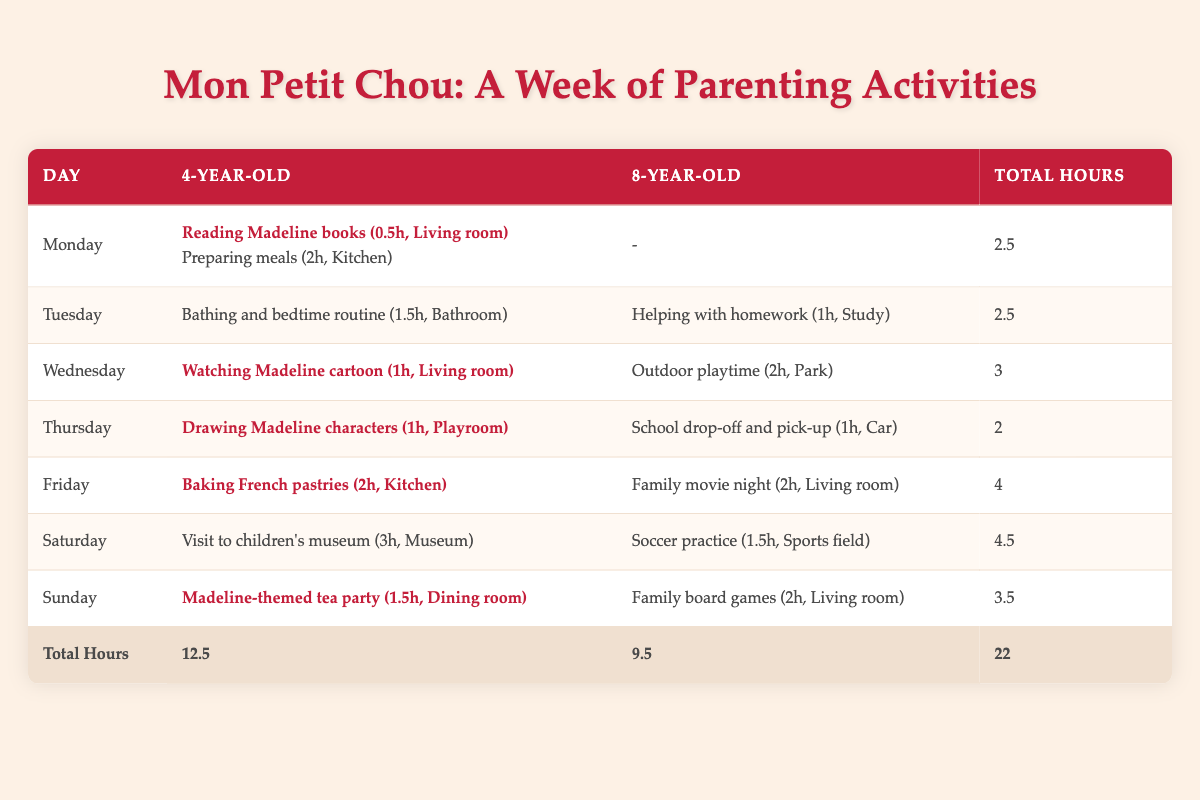What activities involve the 4-year-old on Friday? On Friday, the activities involving the 4-year-old are "Baking French pastries" which takes 2 hours in the Kitchen.
Answer: Baking French pastries (2h, Kitchen) What is the total time spent with the 8-year-old on Sunday? On Sunday, the only activity involving the 8-year-old is "Family board games," which takes 2 hours in the Living room.
Answer: 2 Which day has the highest total hours spent overall? By comparing the total hours for each day from the last column, Saturday has the highest total of 4.5 hours.
Answer: Saturday What is the total time spent on Madeline-related activities for the 4-year-old? Adding the time spent on "Reading Madeline books" (0.5h), "Watching Madeline cartoon" (1h), "Drawing Madeline characters" (1h), and "Madeline-themed tea party" (1.5h) gives a total of 4 hours.
Answer: 4 Is the time spent on the 8-year-old greater than the time spent on the 4-year-old for the whole week? The total time spent on the 4-year-old is 12.5 hours, while for the 8-year-old it is 9.5 hours, so the 4-year-old has more time spent.
Answer: No Which activity takes the longest time for the 4-year-old and on which day? The "Visit to children's museum" on Saturday takes the longest time at 3 hours for the 4-year-old.
Answer: Visit to children's museum, Saturday What is the average time spent per day on activities for the 4-year-old? The total time spent on activities for the 4-year-old is 12.5 hours over 7 days, so the average is 12.5 / 7 = approximately 1.79 hours per day.
Answer: Approximately 1.79 hours How many different locations are involved in activities for the 8-year-old? The locations for the activities of the 8-year-old are Study, Park, Car, and Living room, totaling 4 different locations.
Answer: 4 Which activity was done the least amount of time for the 4-year-old and what day did it take place? The activity "Reading Madeline books" was done for only 0.5 hours on Monday, which is the least amount of time.
Answer: Reading Madeline books, Monday 